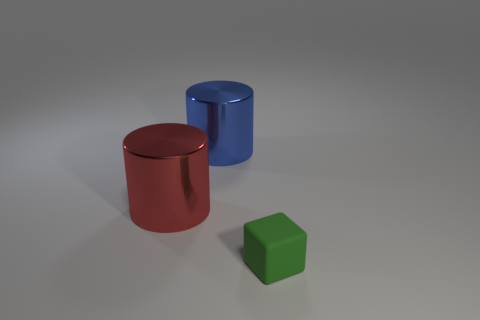Is there a big thing that has the same color as the tiny cube?
Ensure brevity in your answer.  No. There is a tiny matte cube; is its color the same as the large cylinder to the right of the big red object?
Offer a terse response. No. The object that is right of the shiny thing that is behind the red metallic object is what color?
Your answer should be compact. Green. Are there any red objects to the right of the big cylinder that is left of the metal thing that is on the right side of the red metallic cylinder?
Offer a very short reply. No. What is the color of the other cylinder that is the same material as the red cylinder?
Offer a terse response. Blue. What number of large things are the same material as the big blue cylinder?
Keep it short and to the point. 1. Do the large blue thing and the big thing left of the large blue cylinder have the same material?
Keep it short and to the point. Yes. What number of things are either things that are to the left of the blue thing or metal cylinders?
Your answer should be very brief. 2. There is a metal cylinder in front of the object behind the big shiny thing that is left of the blue shiny cylinder; how big is it?
Keep it short and to the point. Large. Are there any other things that are the same shape as the red object?
Ensure brevity in your answer.  Yes. 